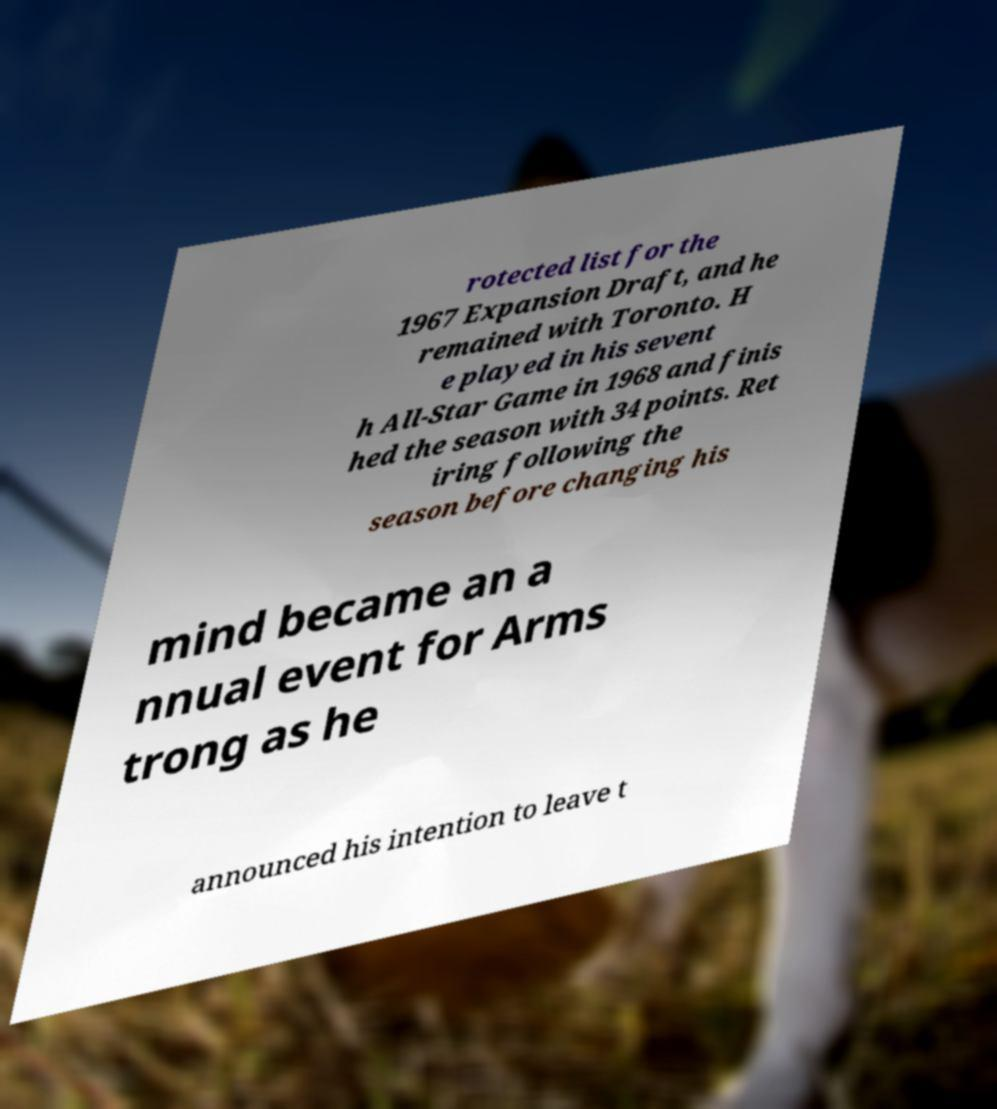Please identify and transcribe the text found in this image. rotected list for the 1967 Expansion Draft, and he remained with Toronto. H e played in his sevent h All-Star Game in 1968 and finis hed the season with 34 points. Ret iring following the season before changing his mind became an a nnual event for Arms trong as he announced his intention to leave t 